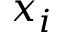Convert formula to latex. <formula><loc_0><loc_0><loc_500><loc_500>x _ { i }</formula> 